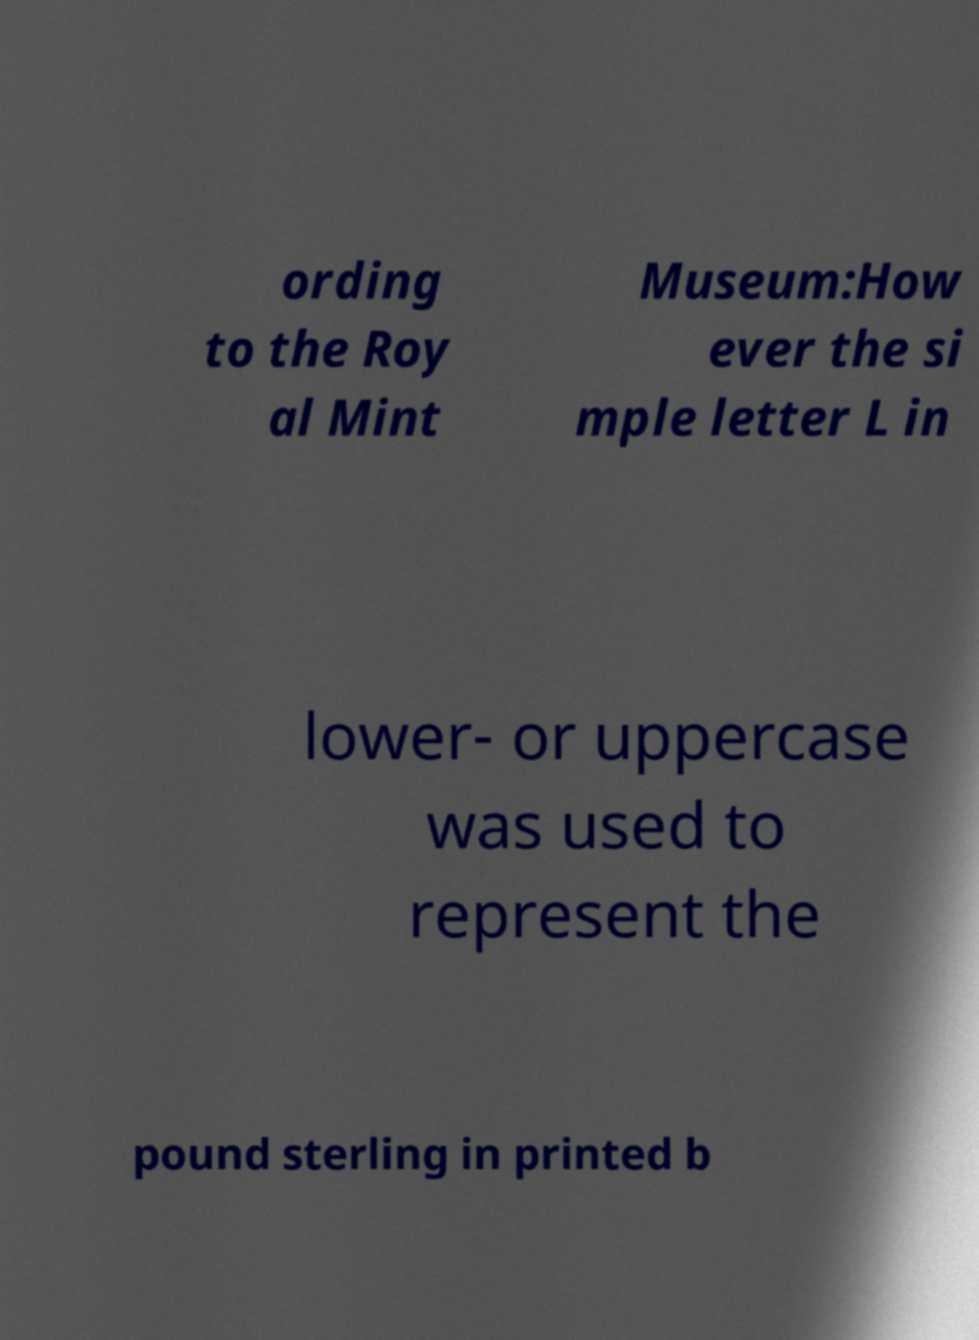For documentation purposes, I need the text within this image transcribed. Could you provide that? ording to the Roy al Mint Museum:How ever the si mple letter L in lower- or uppercase was used to represent the pound sterling in printed b 